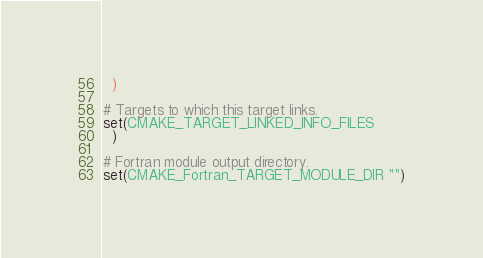<code> <loc_0><loc_0><loc_500><loc_500><_CMake_>  )

# Targets to which this target links.
set(CMAKE_TARGET_LINKED_INFO_FILES
  )

# Fortran module output directory.
set(CMAKE_Fortran_TARGET_MODULE_DIR "")
</code> 